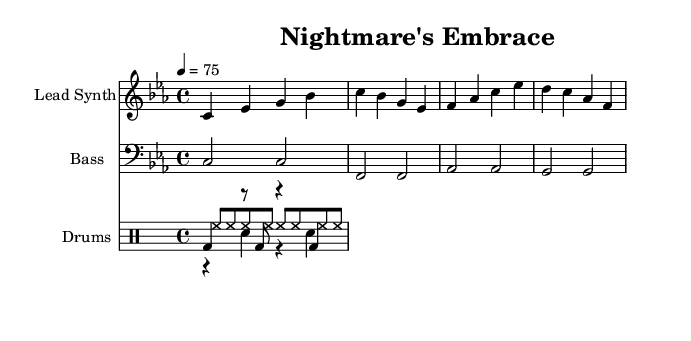What is the key signature of this music? The key signature is indicated at the beginning of the score. In this case, it shows a flat on the B line, indicating that it is in C minor, which has three flats.
Answer: C minor What is the time signature of this score? The time signature is displayed at the beginning of the piece, specifically as a fraction. Here, it is written as 4/4, which means there are four beats in each measure.
Answer: 4/4 What is the tempo marking for this piece? The tempo is indicated in beats per minute. In this score, it shows 4 = 75, indicating that the quarter note is played at a speed of 75 beats per minute.
Answer: 75 How many measures are in the lead synth part? To determine the number of measures, count the distinct sections divided by vertical lines. The lead synth part has a total of four measures.
Answer: 4 What is the instrument used for the bass line? The staff labeled as Bass uses the bass clef, which signifies that it is designed for bass instruments like the bass guitar or double bass.
Answer: Bass What is the difference between the kick drum and snare drum rhythm patterns? The kick drum pattern consists of a combination of notes and rests purely on quarter notes, while the snare pattern consists of a mix of rests and snare hits. This contrast creates a unique rhythm in the percussion section.
Answer: Kick and snare rhythms differ What mood does the harmonic structure evoke in the context of horrorcore rap? The use of C minor and the specific melodic and rhythmic choices contribute to a dark and eerie atmosphere suitable for horrorcore rap, enhancing feelings of tension and unease common in the genre.
Answer: Dark and eerie 